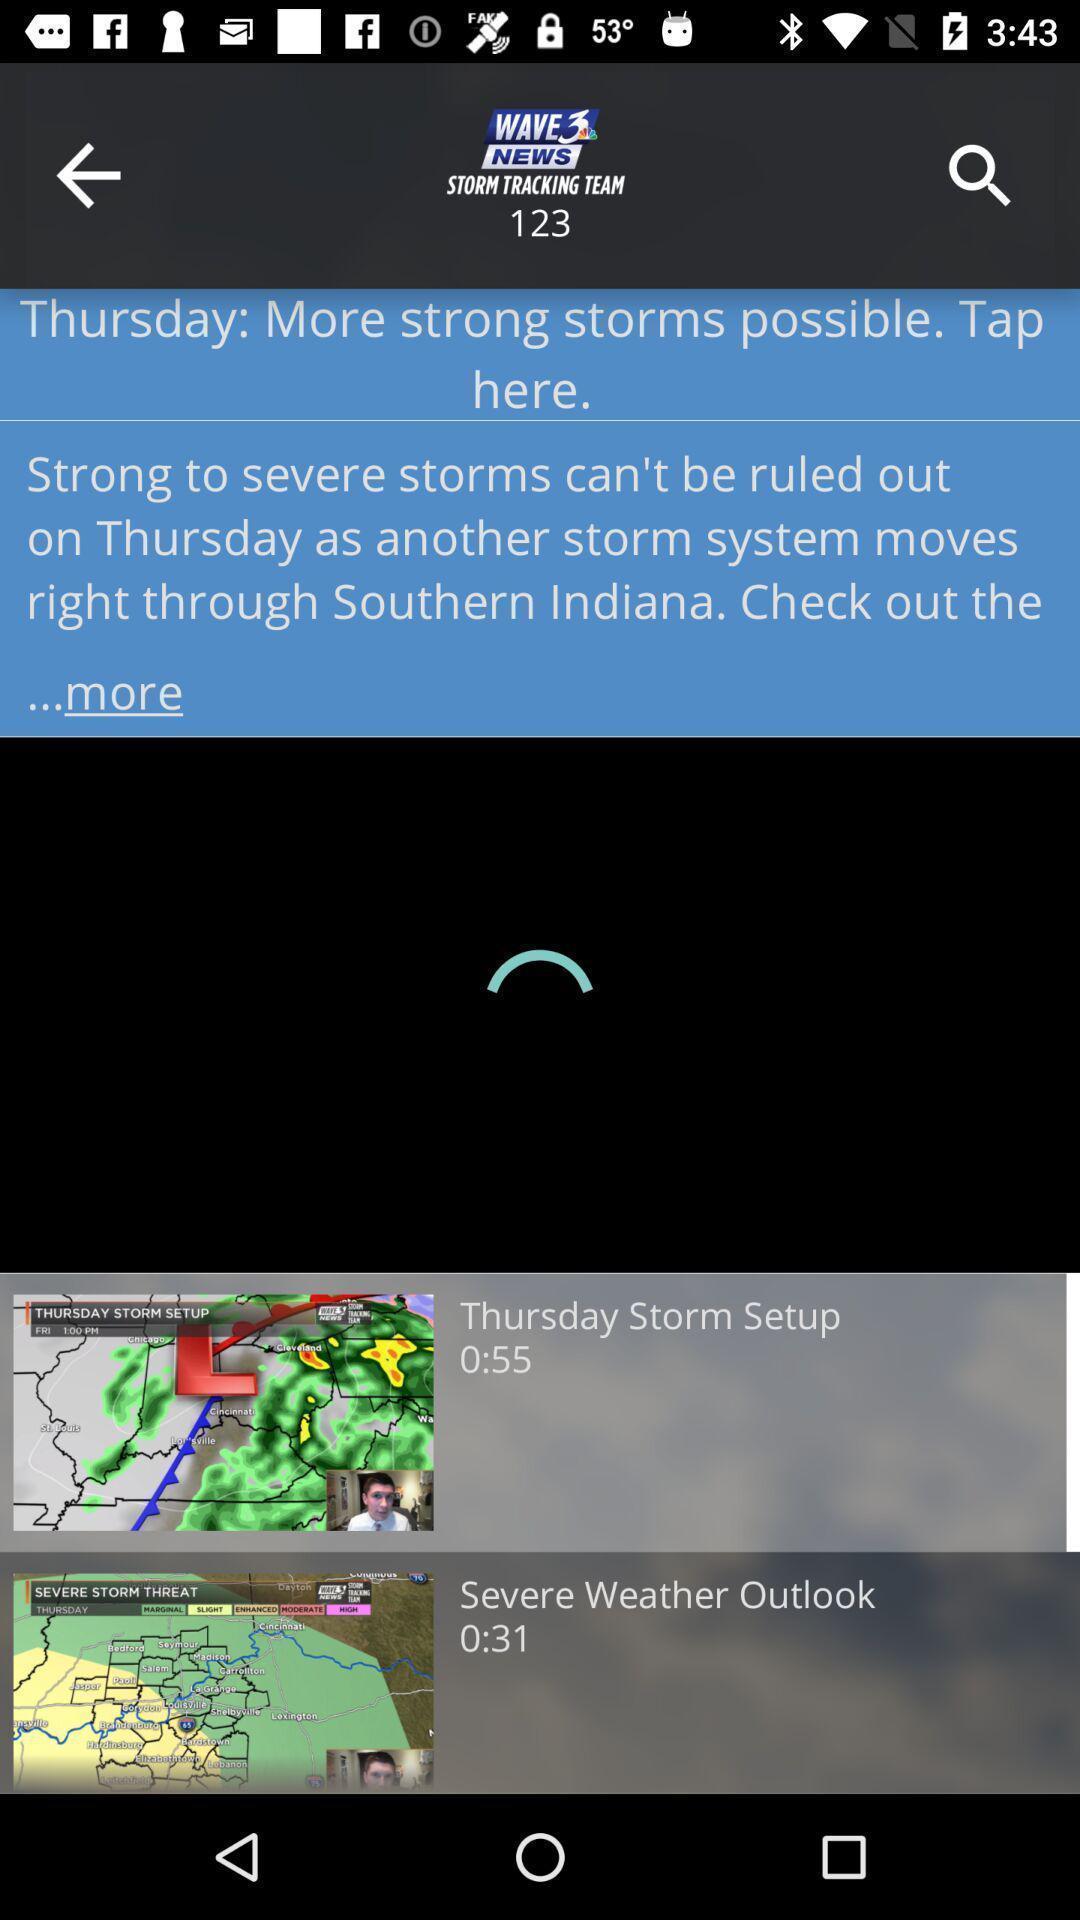Provide a detailed account of this screenshot. Page displaying weather report in the app. 